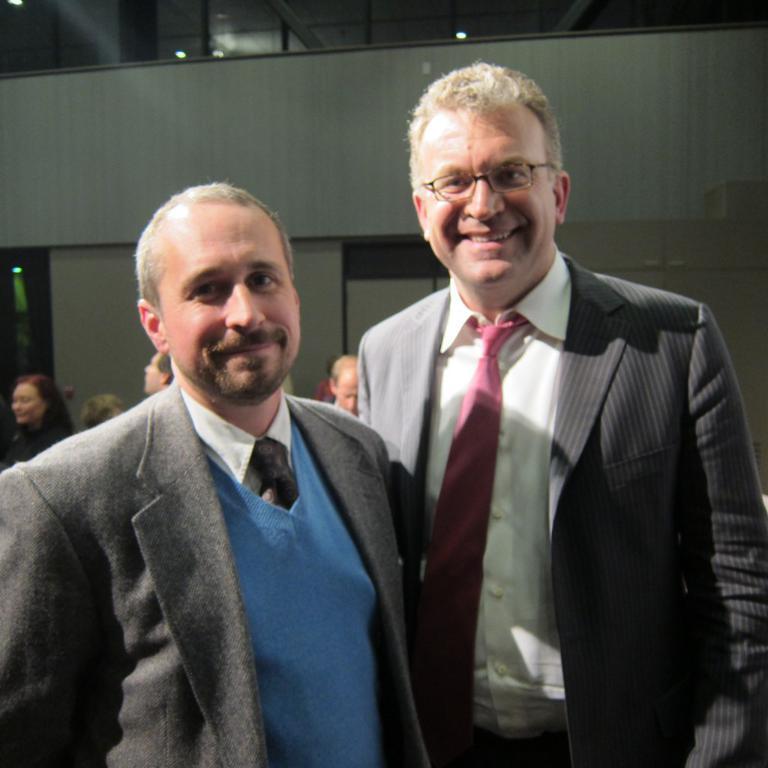Please provide a concise description of this image. Front these two people wore suits. Lights are attached to the ceiling. Background there are people.  